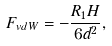Convert formula to latex. <formula><loc_0><loc_0><loc_500><loc_500>F _ { v d W } = - \frac { R _ { 1 } H } { 6 d ^ { 2 } } ,</formula> 